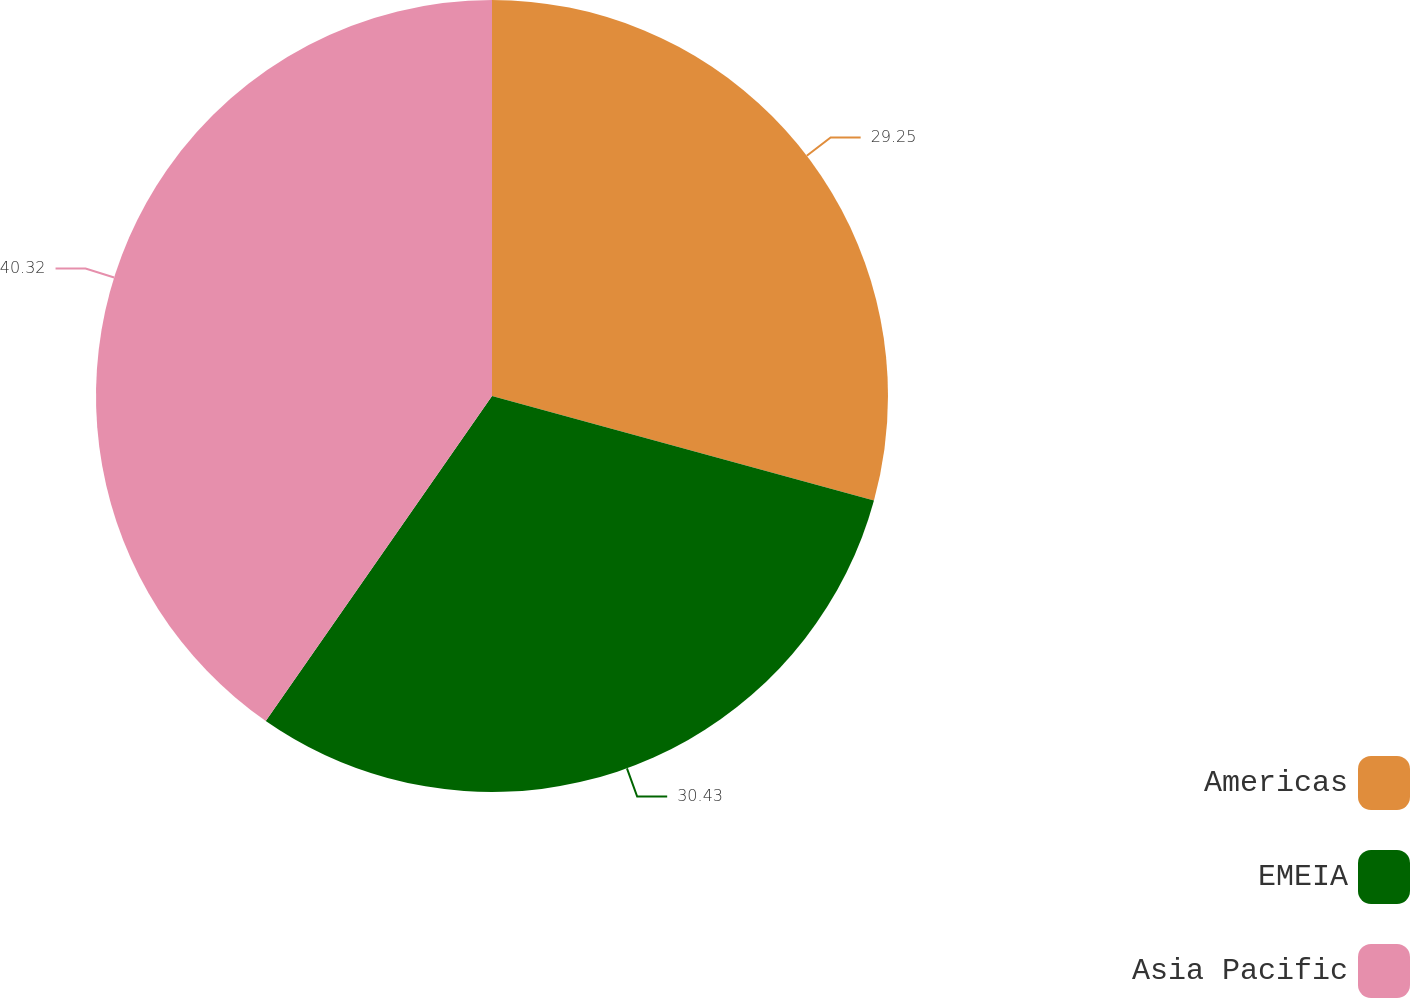Convert chart to OTSL. <chart><loc_0><loc_0><loc_500><loc_500><pie_chart><fcel>Americas<fcel>EMEIA<fcel>Asia Pacific<nl><fcel>29.25%<fcel>30.43%<fcel>40.32%<nl></chart> 